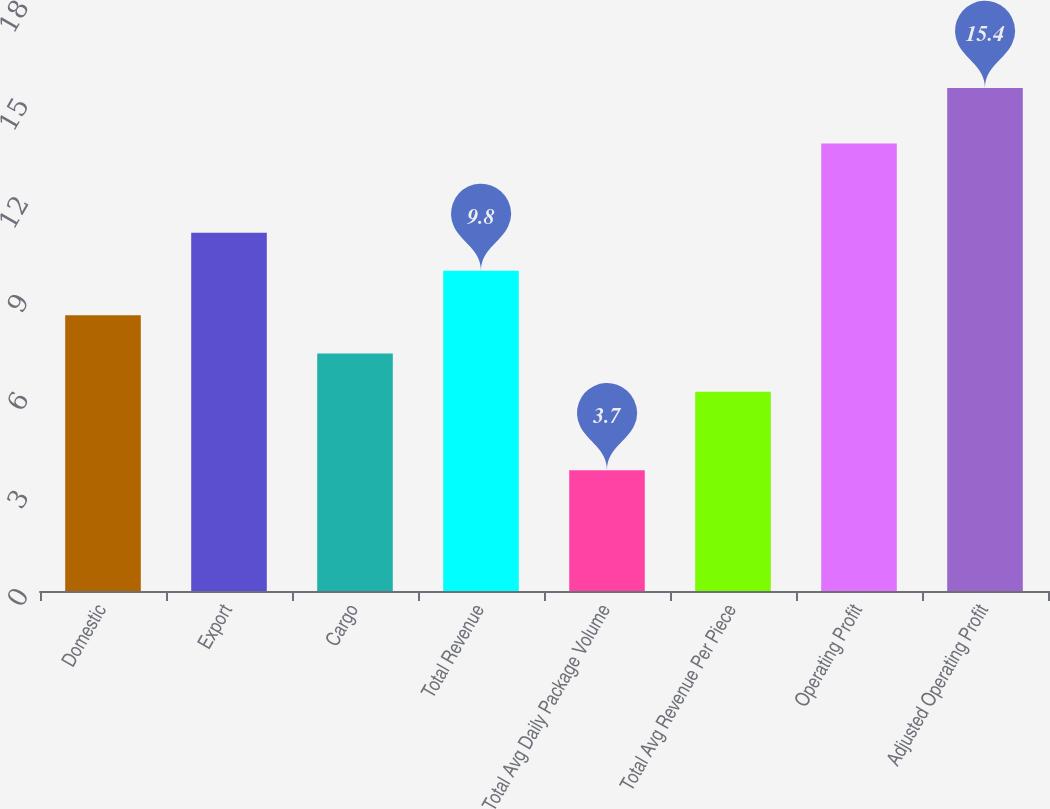Convert chart to OTSL. <chart><loc_0><loc_0><loc_500><loc_500><bar_chart><fcel>Domestic<fcel>Export<fcel>Cargo<fcel>Total Revenue<fcel>Total Avg Daily Package Volume<fcel>Total Avg Revenue Per Piece<fcel>Operating Profit<fcel>Adjusted Operating Profit<nl><fcel>8.44<fcel>10.97<fcel>7.27<fcel>9.8<fcel>3.7<fcel>6.1<fcel>13.7<fcel>15.4<nl></chart> 